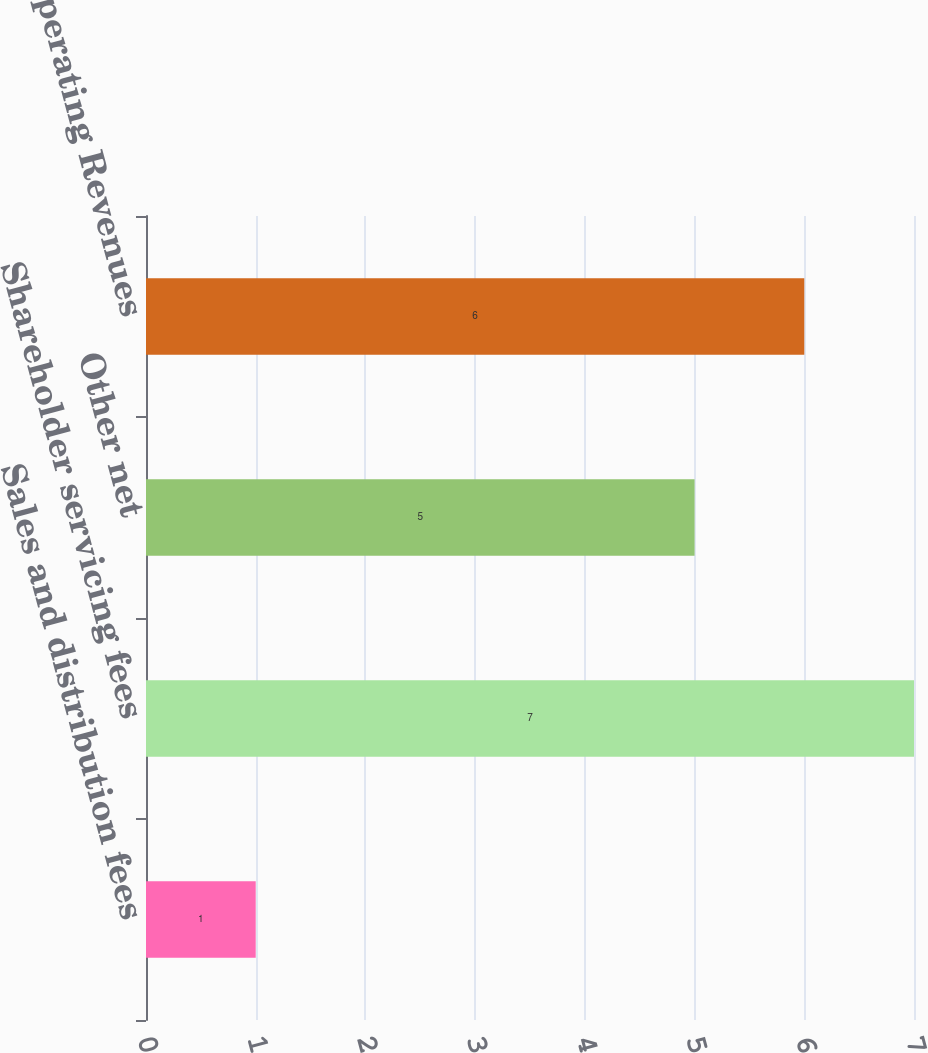Convert chart to OTSL. <chart><loc_0><loc_0><loc_500><loc_500><bar_chart><fcel>Sales and distribution fees<fcel>Shareholder servicing fees<fcel>Other net<fcel>Total Operating Revenues<nl><fcel>1<fcel>7<fcel>5<fcel>6<nl></chart> 